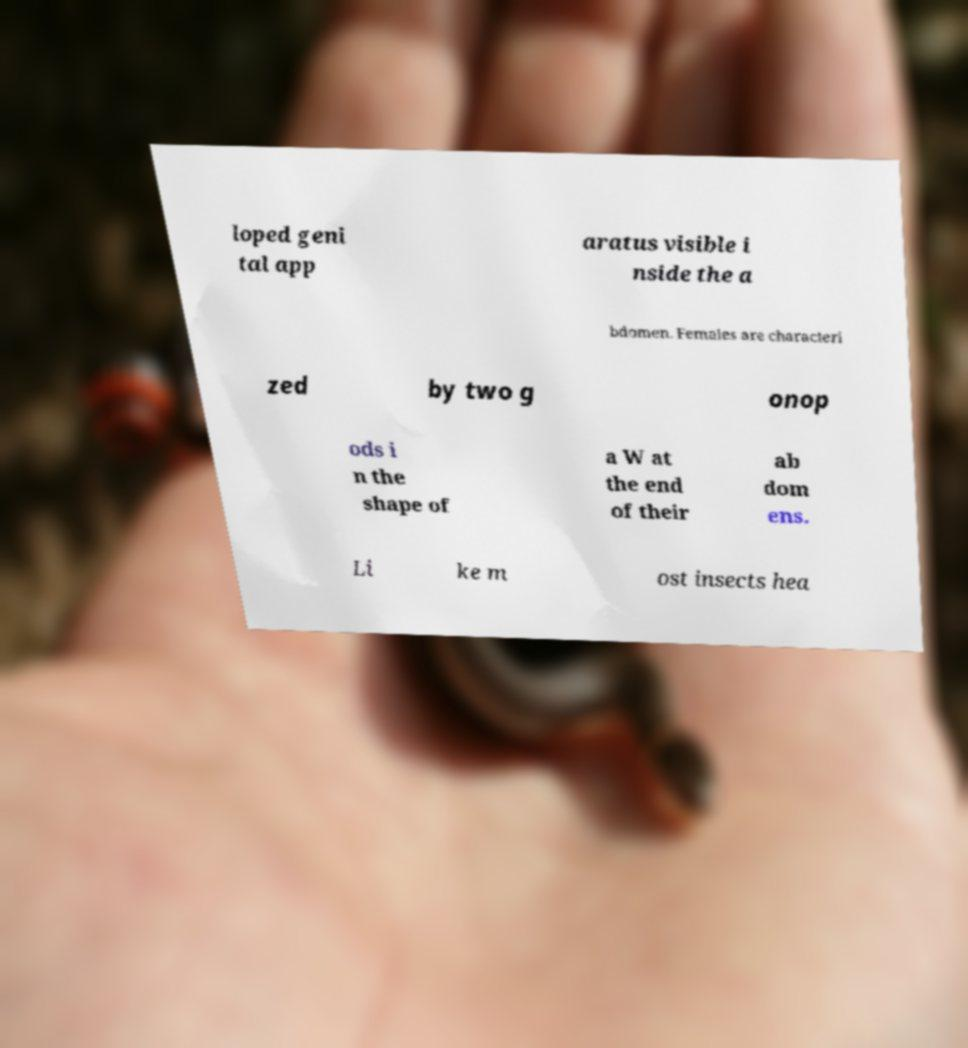There's text embedded in this image that I need extracted. Can you transcribe it verbatim? loped geni tal app aratus visible i nside the a bdomen. Females are characteri zed by two g onop ods i n the shape of a W at the end of their ab dom ens. Li ke m ost insects hea 